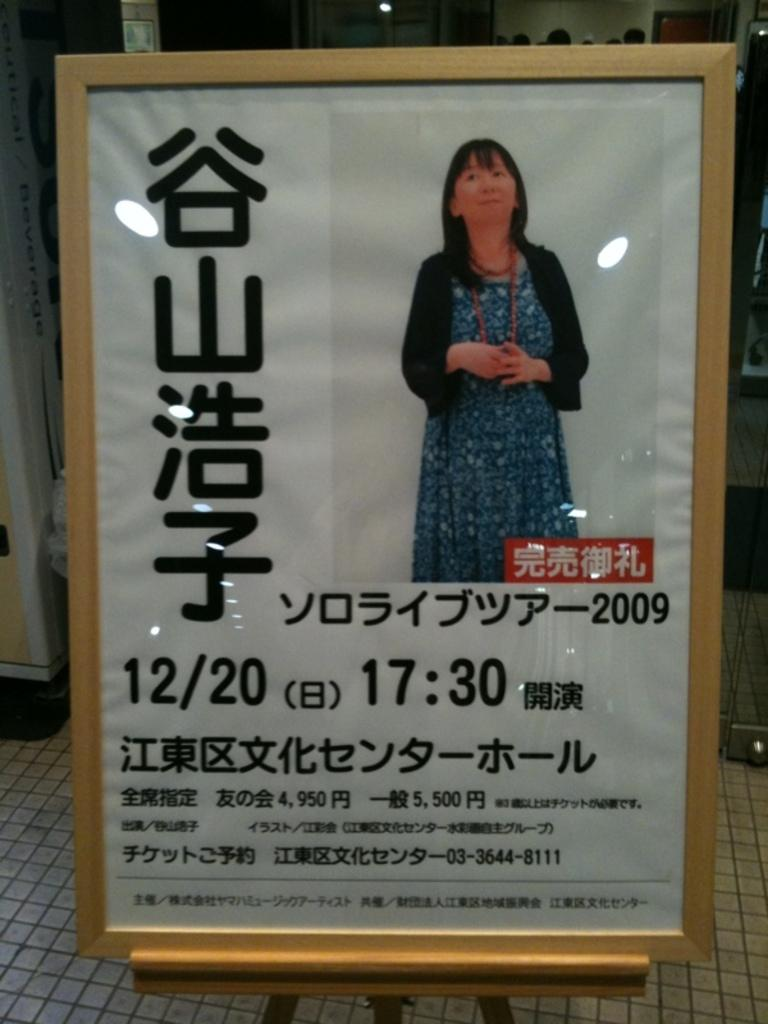What is the main object in the image? There is a board with an image and text in the image. How is the board positioned in the image? The board is placed on a stand. Are there any people present in the image? Yes, there are people standing behind the board. What type of quiver can be seen on the board in the image? There is no quiver present on the board in the image; it features an image and text. How does the board change its appearance in the image? The board does not change its appearance in the image; it remains consistent throughout. 